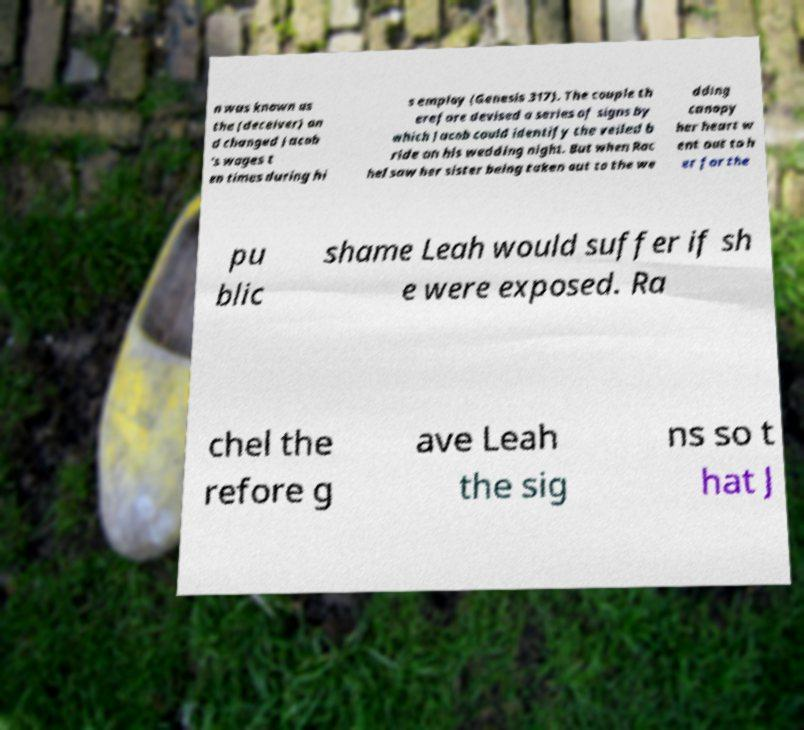Can you accurately transcribe the text from the provided image for me? n was known as the (deceiver) an d changed Jacob 's wages t en times during hi s employ (Genesis 317). The couple th erefore devised a series of signs by which Jacob could identify the veiled b ride on his wedding night. But when Rac hel saw her sister being taken out to the we dding canopy her heart w ent out to h er for the pu blic shame Leah would suffer if sh e were exposed. Ra chel the refore g ave Leah the sig ns so t hat J 